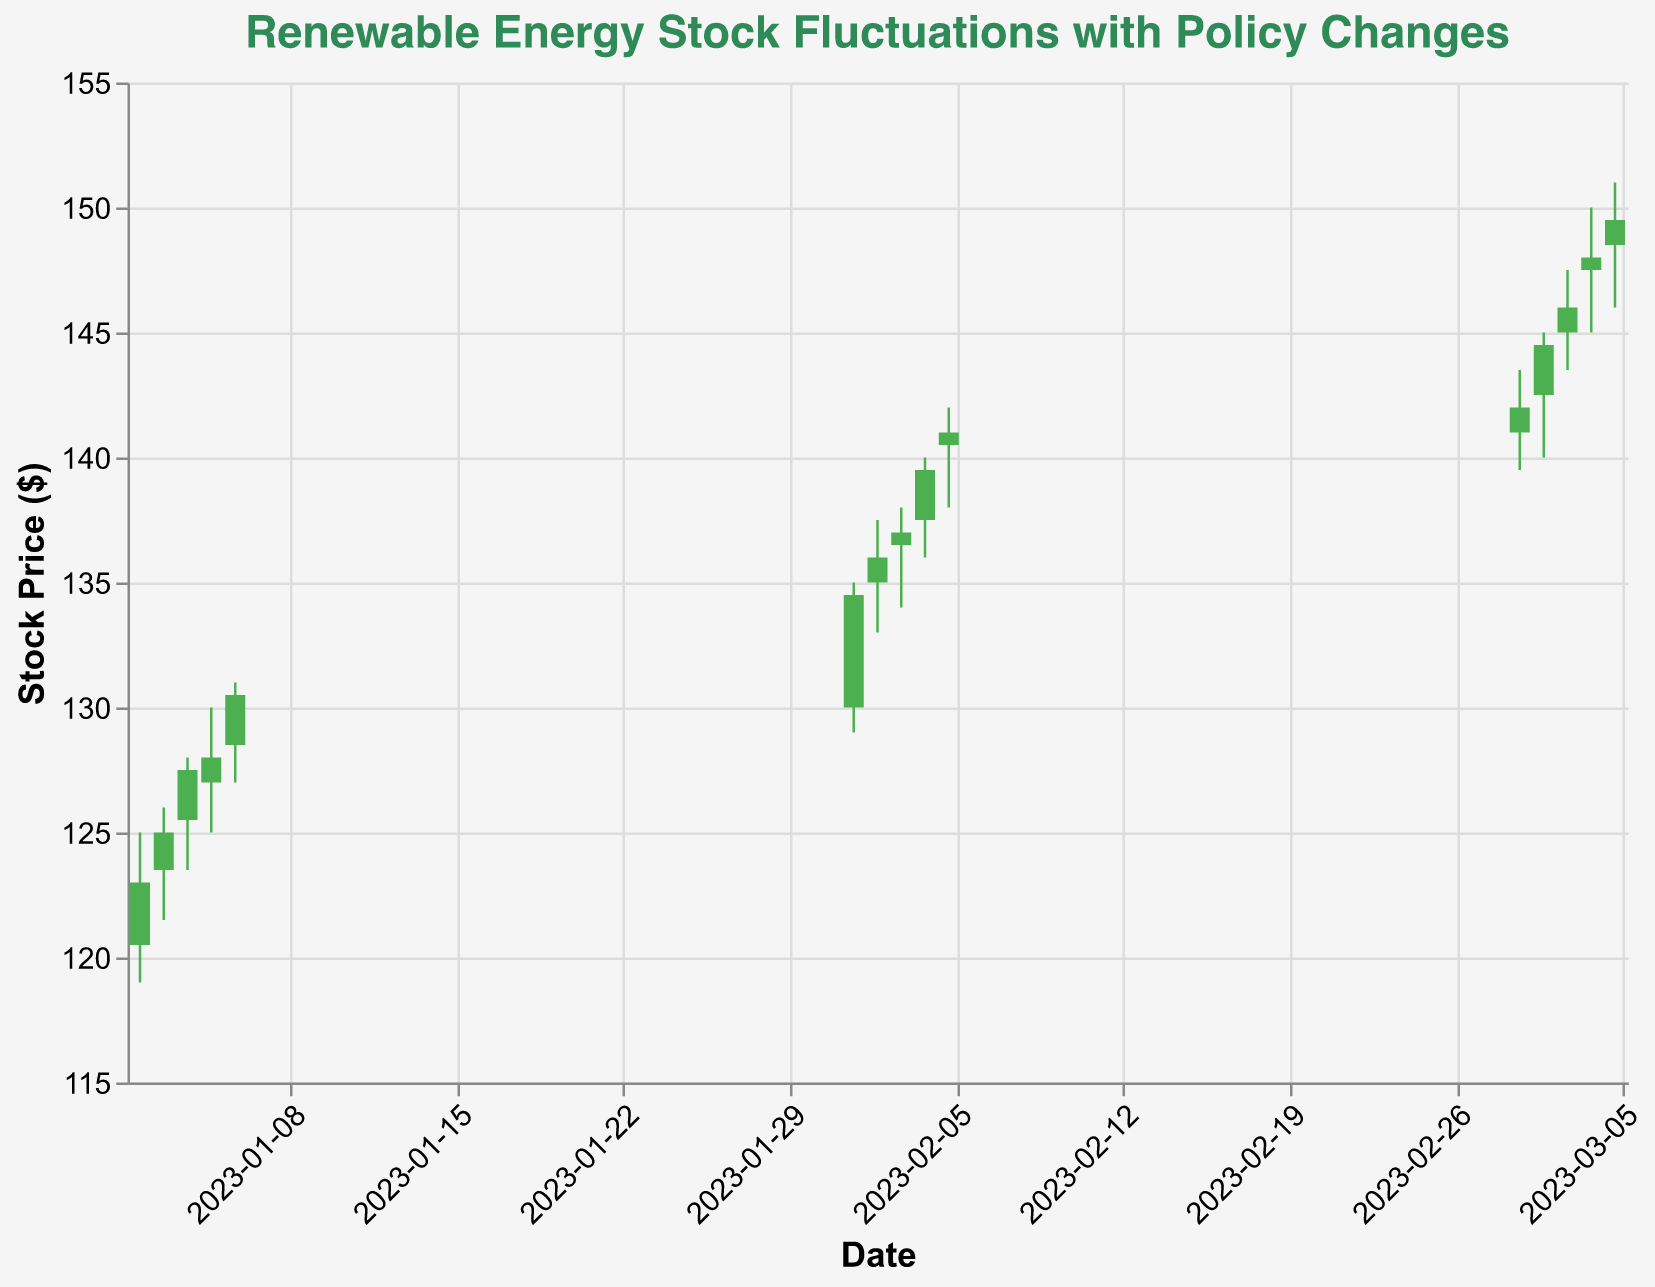What is the title of the plot? The title of the plot is typically placed at the top and often highlights the main focus of the visual representation. In this plot, the title reads "Renewable Energy Stock Fluctuations with Policy Changes".
Answer: Renewable Energy Stock Fluctuations with Policy Changes What colors are used to represent increasing and decreasing stock prices? The colors usually indicate whether stocks are increasing or decreasing. In this plot, green (#4CAF50) represents increasing stock prices, while red (#FF5252) represents decreasing stock prices.
Answer: Green and Red How did the introduction of the carbon tax affect the stock's closing price from January 2 to January 6, 2023? To respond, observe the plot for the dates between January 2 and January 6. The closing prices increase from 123.0 to 130.5. This indicates a positive effect of the carbon tax introduction.
Answer: Increased Which policy change corresponds to the highest volume traded, and what is the volume? The volume traded is represented by the height of the bars. The policy change associated with the maximum volume is "Renewable Energy Investment Tax Credit Extension" on March 5, 2023, where the volume is 225,000.
Answer: Renewable Energy Investment Tax Credit Extension, 225,000 What is the highest closing price observed in the data and on which date did it occur? Look for the highest point in the closing price. This happens on March 5, 2023, with a closing price of 149.5.
Answer: 149.5 on March 5, 2023 What was the percentage increase in the stock price from the close on February 1, 2023, to the close on February 5, 2023? First, compute the difference between the closing prices: 141.0 - 134.5 = 6.5. Next, find the percentage: (6.5 / 134.5) * 100 ≈ 4.83%.
Answer: Approximately 4.83% Compare the stock performance during policy changes involving the 'Introduction of Carbon Tax' and the 'Renewable Energy Investment Tax Credit Extension'. Which period saw a greater increase? Calculate the difference in closing prices for both periods. For the Introduction of Carbon Tax, from 123.0 to 130.5 (7.5 increase). For the Renewable Energy Investment Tax Credit Extension, from 142.0 to 149.5 (7.5 increase). Both periods saw the same increase of 7.5.
Answer: Both periods saw the same increase of 7.5 What pattern do you observe in the stock price movement during the period of 'Removal of Subsidies for Fossil Fuels'? Examine the plot from February 1 to February 5. The stock prices show a consistent increase daily.
Answer: Consistent daily increase How does the stock's price range (high minus low) on February 2, 2023, compare to that on March 2, 2023? Calculate the range for both dates: February 2 - (137.5 - 133.0) = 4.5, and March 2 - (145.0 - 140.0) = 5.0. March 2 has a higher range.
Answer: March 2 has a higher range What policy change is associated with the most significant price increase in a single day, and what is the amount of this increase? Check the differences in closing prices day-over-day. The most significant increase happens on February 4, 2023, associated with the 'Removal of Subsidies for Fossil Fuels', with an increase of 2.5 (from 137.0 to 139.5).
Answer: Removal of Subsidies for Fossil Fuels, 2.5 